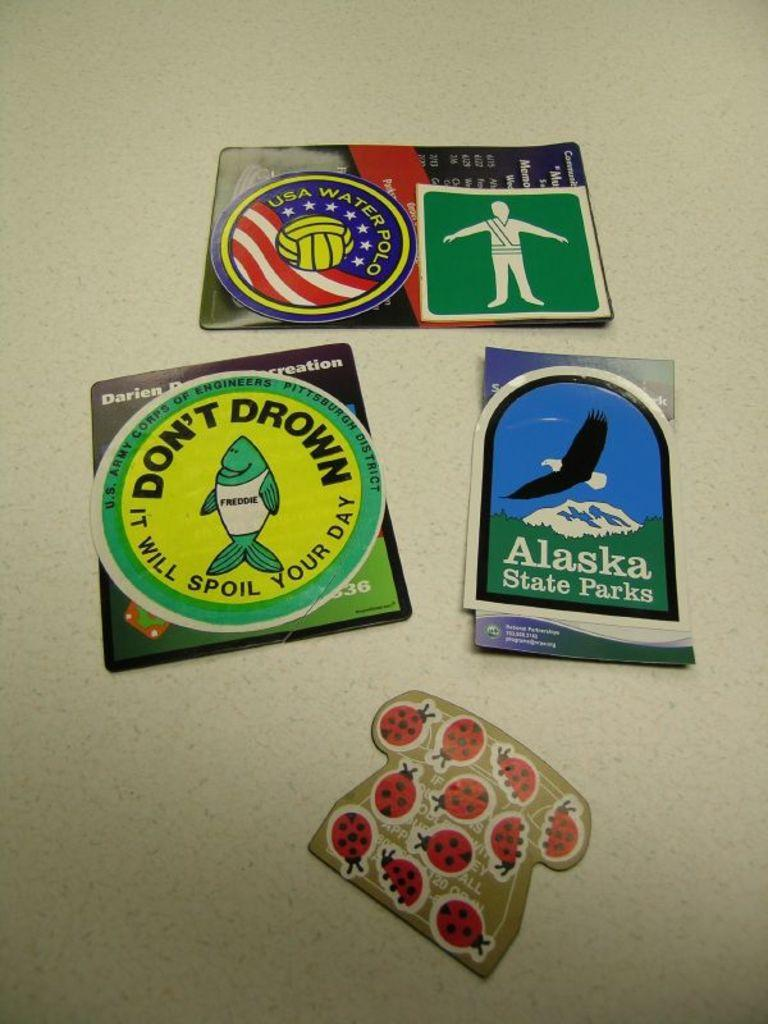What type of visuals are present in the image? There are posters and stickers in the image. What subject matter is featured on the posters and stickers? The posters and stickers depict an insect. What type of stitch is used to create the insect scene on the side of the image? There is no stitching or scene present in the image; it features posters and stickers depicting an insect. 